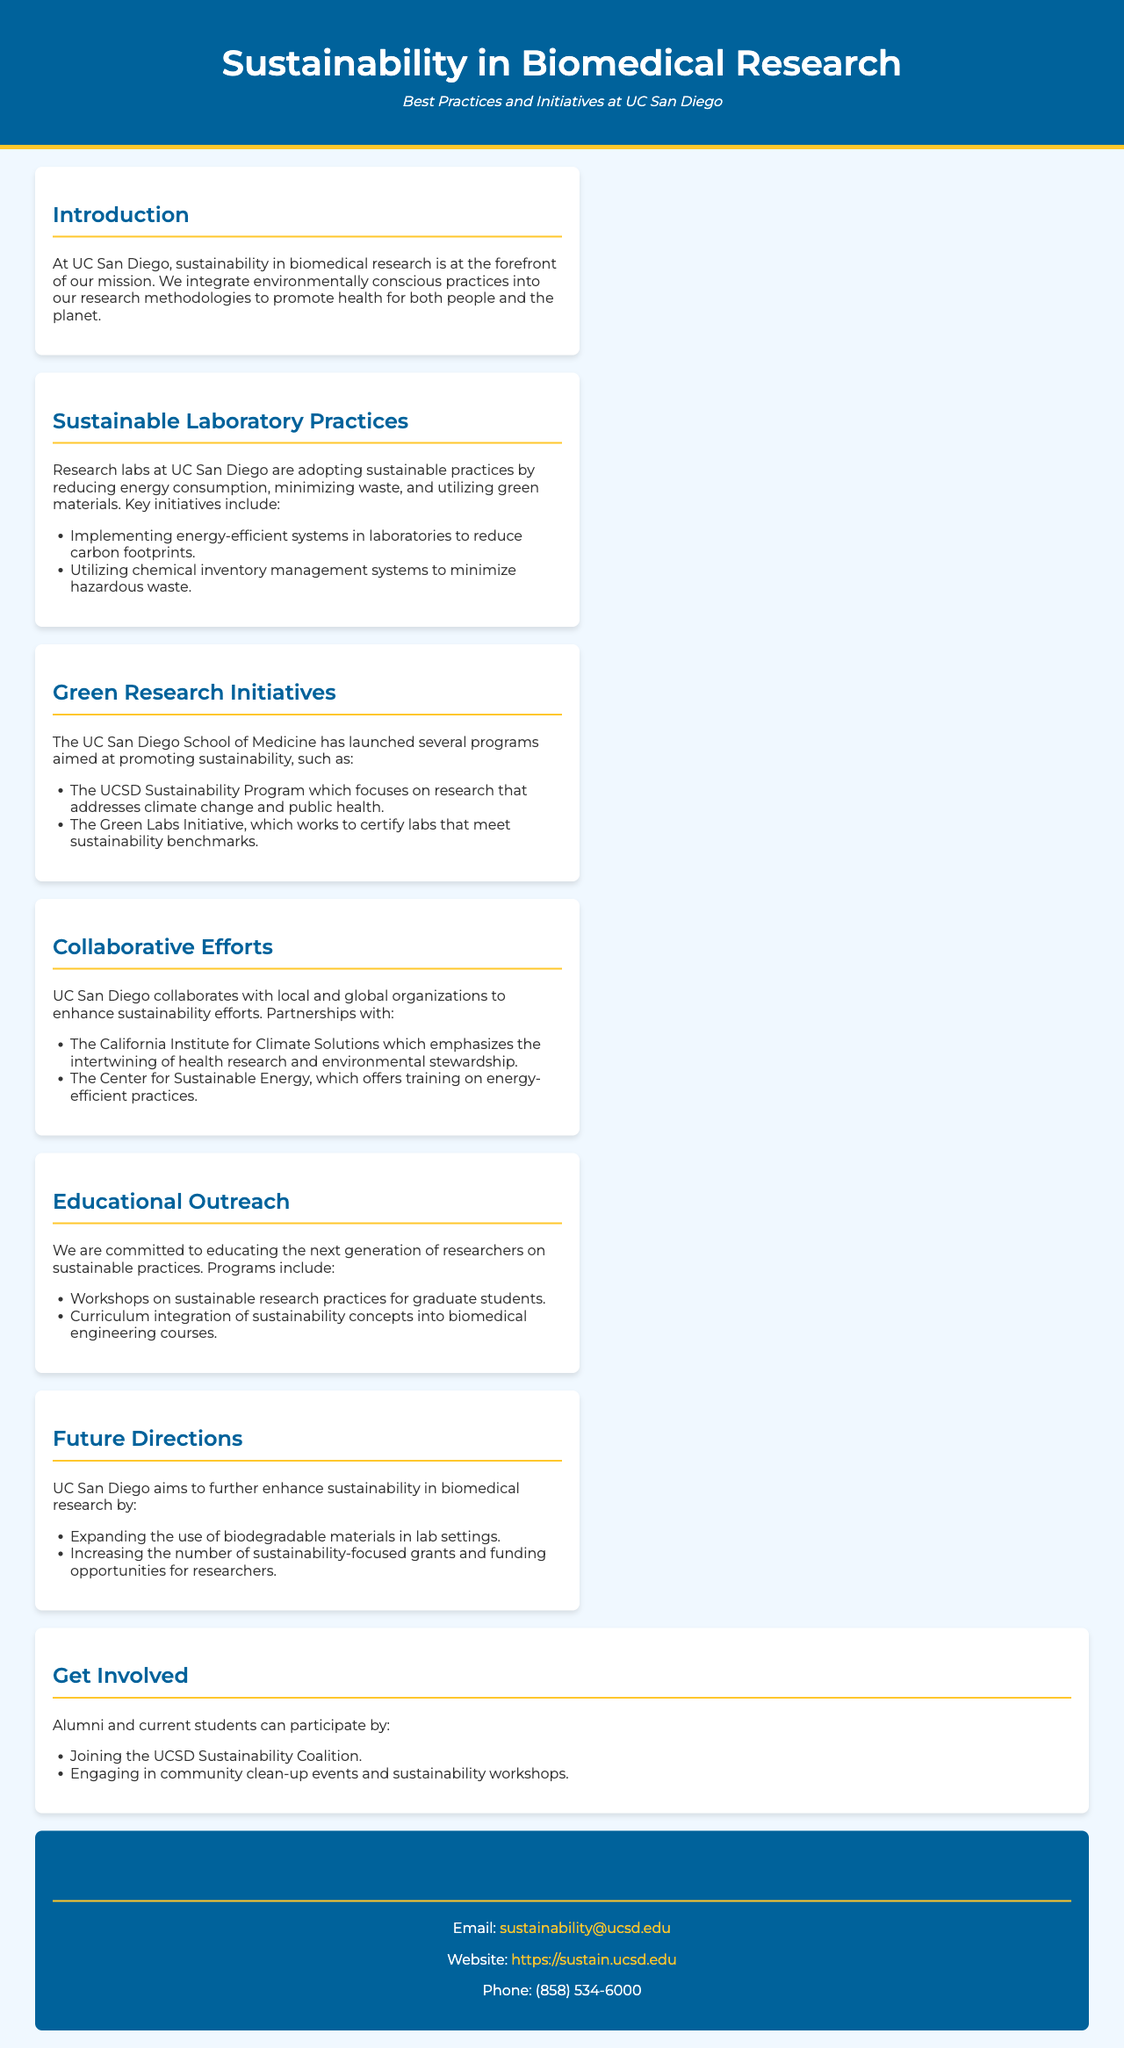What is the title of the brochure? The title of the brochure is indicated at the top of the document, highlighting the main focus of the content.
Answer: Sustainability in Biomedical Research What two key initiatives aim to enhance sustainability at UC San Diego? The document outlines specific programs aimed at promoting sustainability within the institution, which are listed in one of the sections.
Answer: UCSD Sustainability Program and Green Labs Initiative Which organization focuses on the connection between health research and environmental stewardship? The document mentions a partnership with a specific organization that emphasizes both health and environmental aspects.
Answer: California Institute for Climate Solutions What type of workshops is offered to graduate students? The document provides details about educational programs, including the type of workshops available to foster sustainable practices among students.
Answer: Workshops on sustainable research practices What does UC San Diego aim to expand the use of in lab settings? The future directions outlined in the document include intentions for adopting specific materials in laboratories.
Answer: Biodegradable materials How can alumni get involved in sustainability efforts? The document suggests specific ways for alumni and students to participate in sustainability initiatives at UC San Diego.
Answer: Joining the UCSD Sustainability Coalition What is the email contact for sustainability inquiries? The document provides a specific email address for those interested in sustainability-related questions or comments.
Answer: sustainability@ucsd.edu How many key areas are mentioned in the "Sustainable Laboratory Practices" section? The section lists multiple initiatives, and the total number of key areas can be identified from the details provided.
Answer: Two What educational level does the curriculum integration focus on? The document specifies the target educational level for integrating sustainability concepts in courses.
Answer: Graduate students 